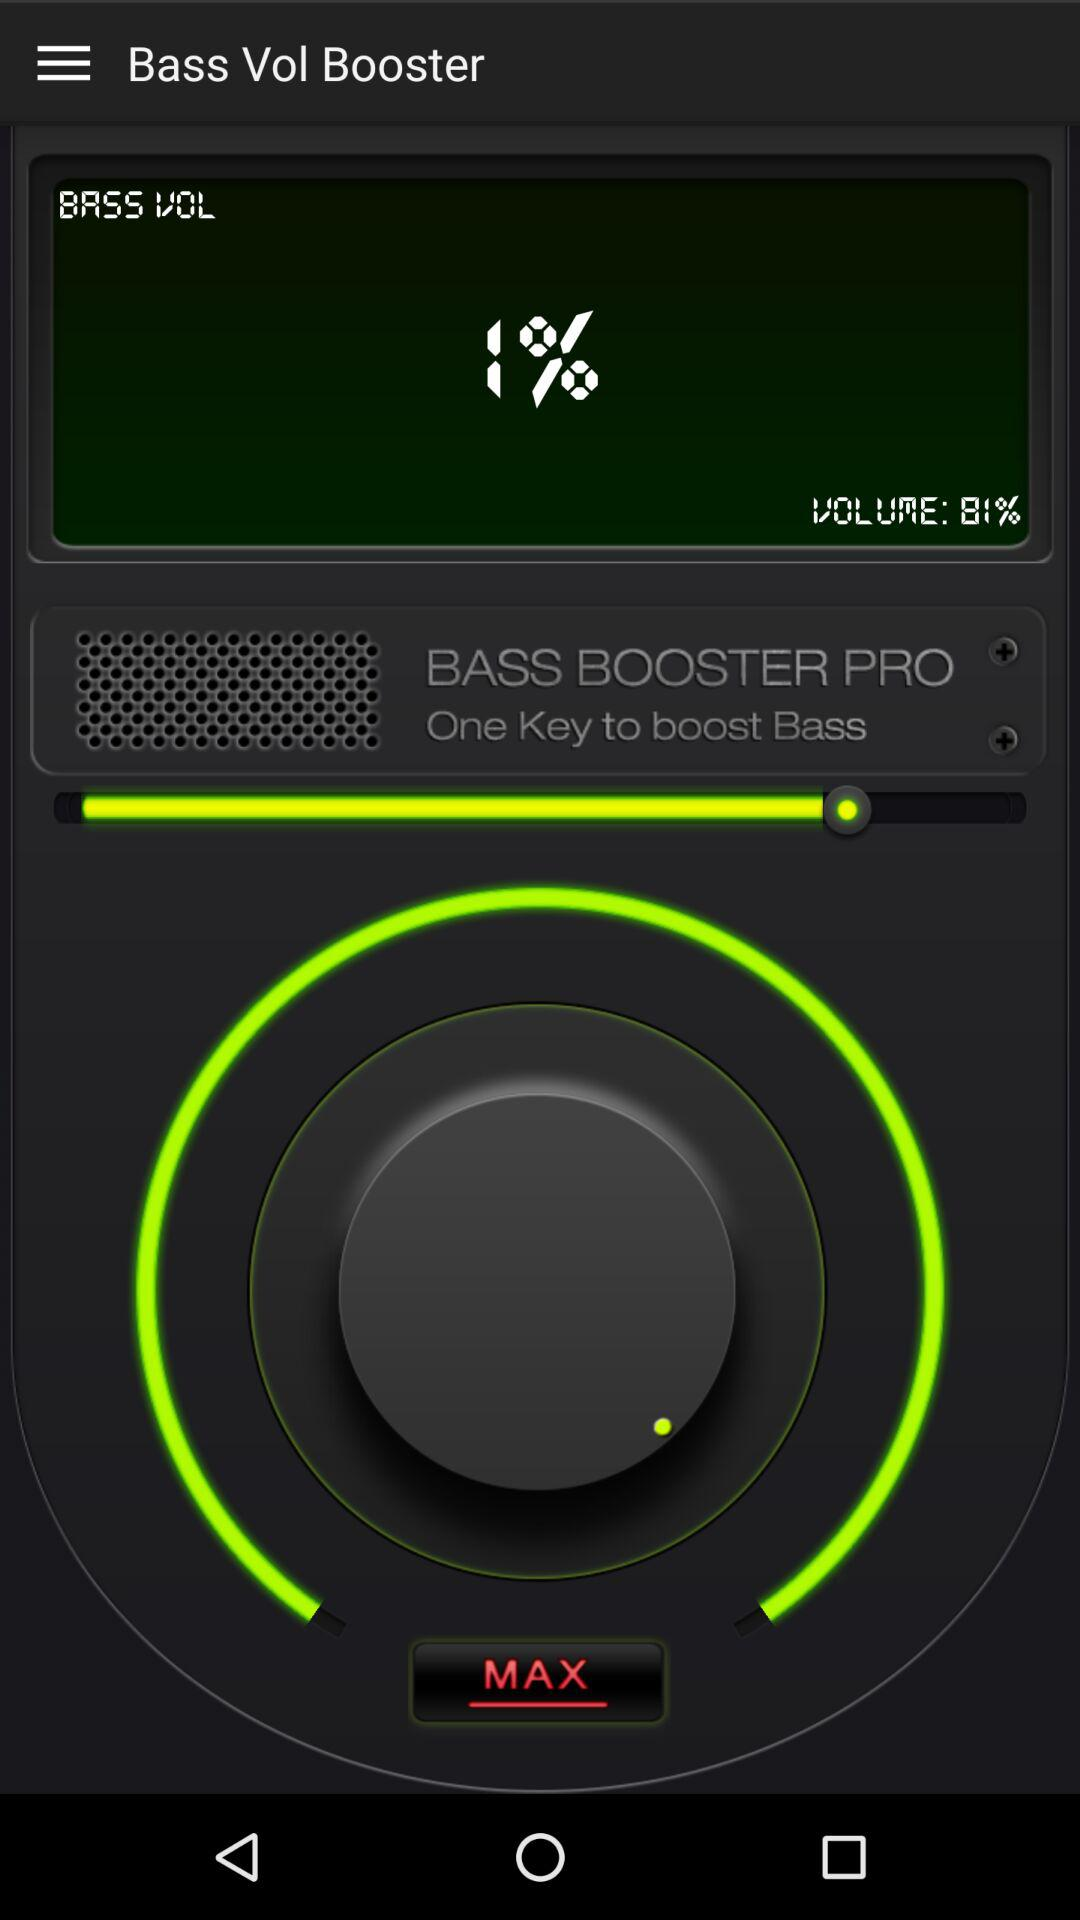What's the bass volume percentage? The bass volume percentage is 1. 